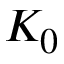<formula> <loc_0><loc_0><loc_500><loc_500>K _ { 0 }</formula> 